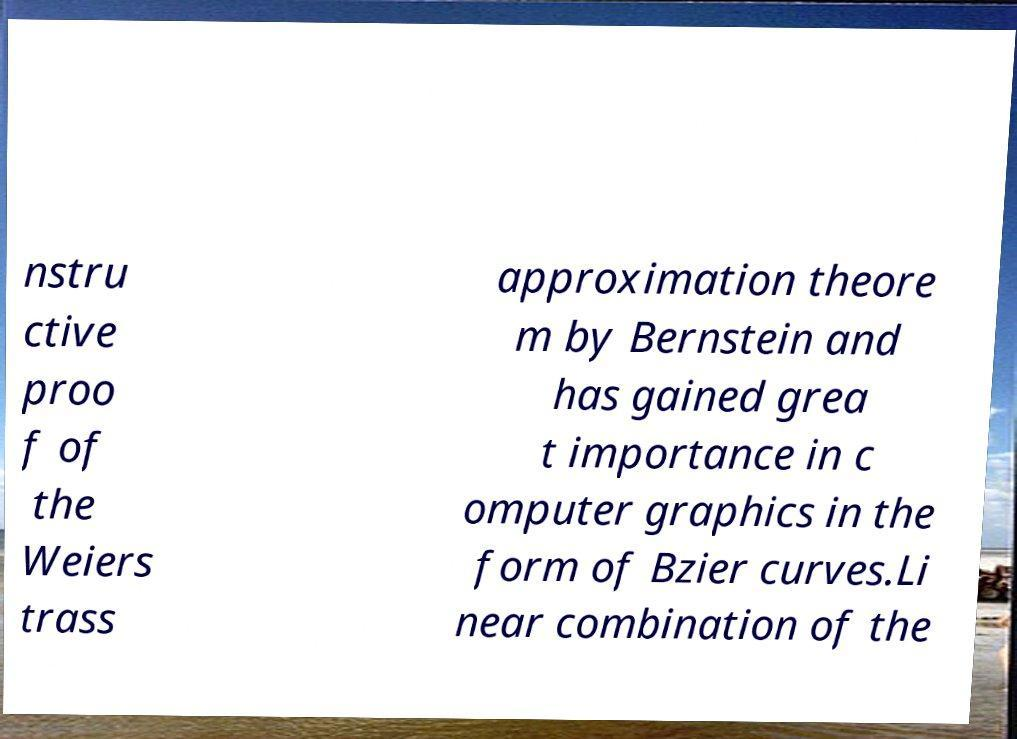Can you accurately transcribe the text from the provided image for me? nstru ctive proo f of the Weiers trass approximation theore m by Bernstein and has gained grea t importance in c omputer graphics in the form of Bzier curves.Li near combination of the 